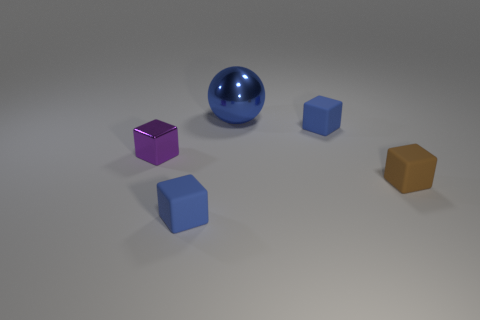Subtract all tiny rubber blocks. How many blocks are left? 1 Add 3 yellow rubber cylinders. How many objects exist? 8 Subtract all blue cubes. How many cubes are left? 2 Add 4 small metallic things. How many small metallic things are left? 5 Add 4 big green matte blocks. How many big green matte blocks exist? 4 Subtract 0 yellow cylinders. How many objects are left? 5 Subtract all cubes. How many objects are left? 1 Subtract 3 blocks. How many blocks are left? 1 Subtract all brown cubes. Subtract all green cylinders. How many cubes are left? 3 Subtract all yellow spheres. How many blue blocks are left? 2 